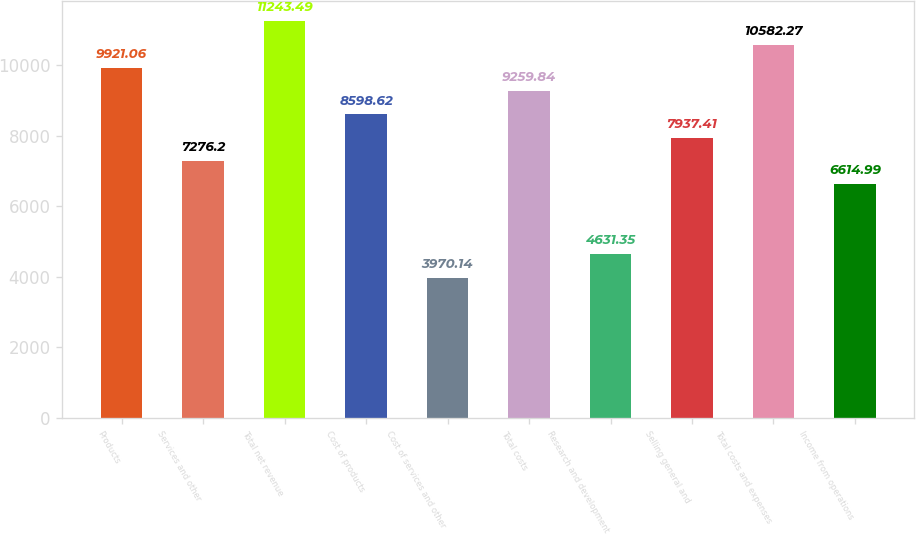<chart> <loc_0><loc_0><loc_500><loc_500><bar_chart><fcel>Products<fcel>Services and other<fcel>Total net revenue<fcel>Cost of products<fcel>Cost of services and other<fcel>Total costs<fcel>Research and development<fcel>Selling general and<fcel>Total costs and expenses<fcel>Income from operations<nl><fcel>9921.06<fcel>7276.2<fcel>11243.5<fcel>8598.62<fcel>3970.14<fcel>9259.84<fcel>4631.35<fcel>7937.41<fcel>10582.3<fcel>6614.99<nl></chart> 